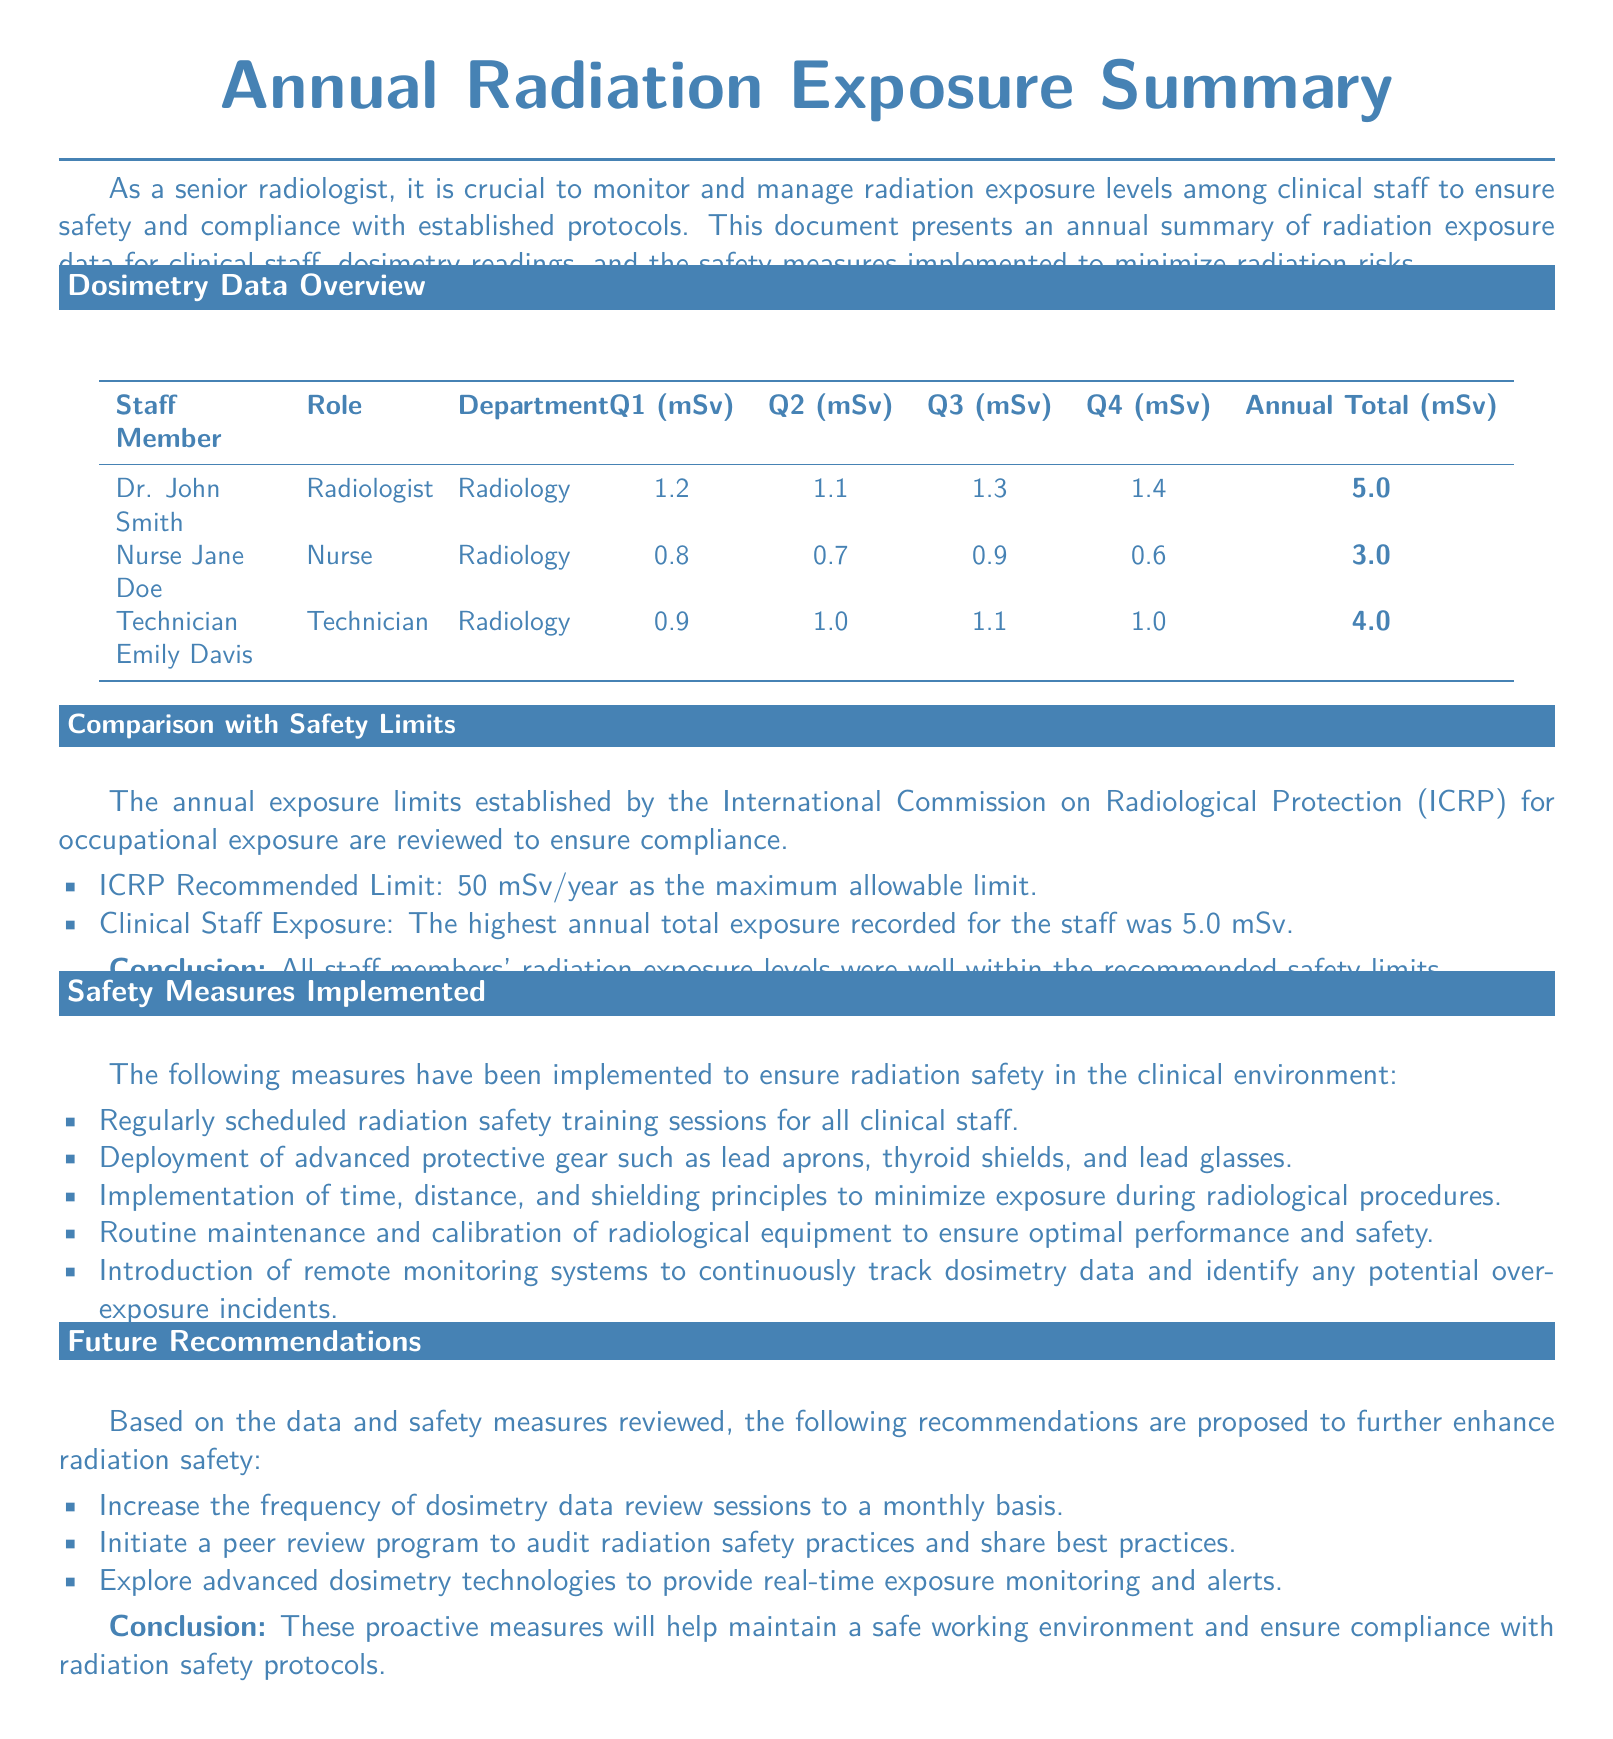What is the total annual exposure for Dr. John Smith? The total annual exposure for Dr. John Smith is calculated from Q1, Q2, Q3, and Q4 readings, which are 1.2 + 1.1 + 1.3 + 1.4 = 5.0 mSv.
Answer: 5.0 mSv What radiation safety measure includes using protective gear? The safety measure that includes using protective gear specifically mentions lead aprons, thyroid shields, and lead glasses as advanced protective measures.
Answer: Deployment of advanced protective gear What is the recommended annual limit set by ICRP? The ICRP recommended limit for occupational exposure is explicitly stated in the document.
Answer: 50 mSv/year Who has the lowest annual radiation exposure among the staff? The staff member with the lowest total radiation exposure is identified from the table where Nurse Jane Doe has an annual total of 3.0 mSv.
Answer: Nurse Jane Doe What future recommendation involves dosimetry data? The future recommendation that involves dosimetry data suggests increasing the frequency of review sessions for monitoring exposure levels.
Answer: Increase frequency of dosimetry data review sessions What was the highest total annual exposure among the clinical staff? The highest total annual exposure recorded among the staff is explicitly noted in the comparison section.
Answer: 5.0 mSv Which department did Technician Emily Davis work in? The department for Technician Emily Davis can be found in the dosimetry data overview where her role and department are listed together.
Answer: Radiology What is the purpose of remote monitoring systems as mentioned in the safety measures? The purpose of remote monitoring systems, as indicated in the safety measures section, is to continuously track dosimetry data.
Answer: Continuously track dosimetry data 